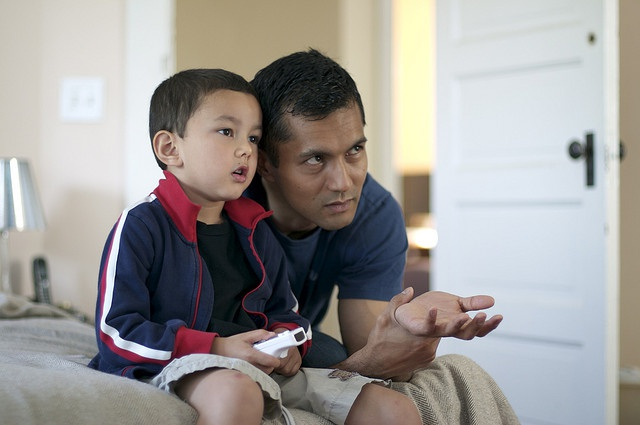Describe the objects in this image and their specific colors. I can see people in lightgray, black, darkgray, and gray tones, people in lightgray, black, gray, and maroon tones, bed in lightgray, darkgray, and gray tones, and remote in lightgray, lavender, darkgray, gray, and black tones in this image. 